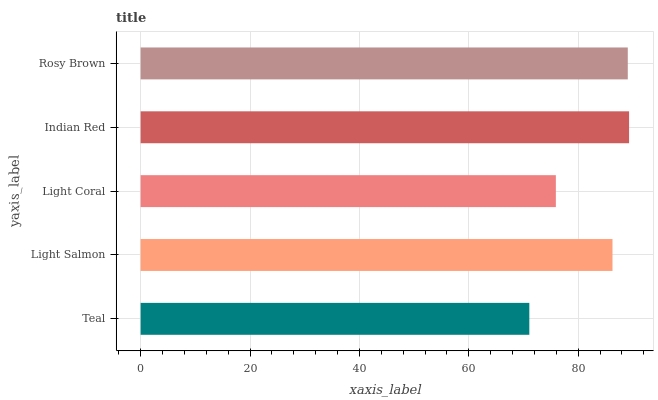Is Teal the minimum?
Answer yes or no. Yes. Is Indian Red the maximum?
Answer yes or no. Yes. Is Light Salmon the minimum?
Answer yes or no. No. Is Light Salmon the maximum?
Answer yes or no. No. Is Light Salmon greater than Teal?
Answer yes or no. Yes. Is Teal less than Light Salmon?
Answer yes or no. Yes. Is Teal greater than Light Salmon?
Answer yes or no. No. Is Light Salmon less than Teal?
Answer yes or no. No. Is Light Salmon the high median?
Answer yes or no. Yes. Is Light Salmon the low median?
Answer yes or no. Yes. Is Indian Red the high median?
Answer yes or no. No. Is Indian Red the low median?
Answer yes or no. No. 